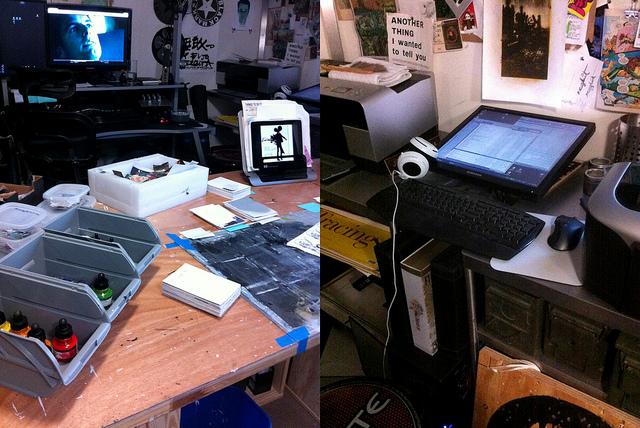Is the computer on?
Short answer required. Yes. What color is the desk on the left?
Quick response, please. Brown. Is this a office?
Keep it brief. Yes. 